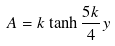Convert formula to latex. <formula><loc_0><loc_0><loc_500><loc_500>A = k \tanh \frac { 5 k } { 4 } y</formula> 